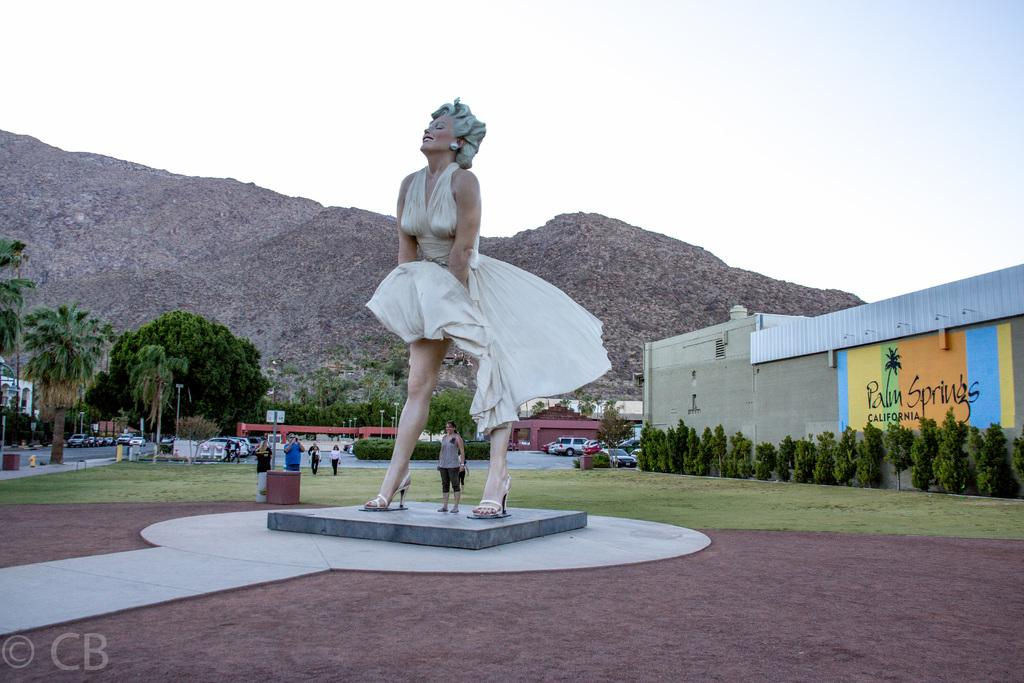What is the main subject in the center of the image? There is a statue in the center of the image. Can you describe the people in the image? There are people in the image, but their specific actions or positions are not mentioned in the facts. What can be seen in the background of the image? In the background of the image, there are trees, bushes, cars, poles, hills, and the sky. Where is the shed located in the image? The shed is on the right side of the image. How do the people in the image fold the sail? There is no mention of a sail or any folding activity in the image. 